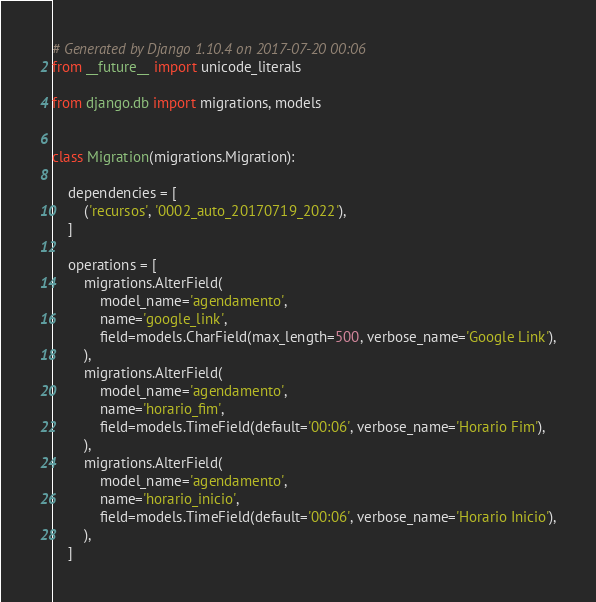Convert code to text. <code><loc_0><loc_0><loc_500><loc_500><_Python_># Generated by Django 1.10.4 on 2017-07-20 00:06
from __future__ import unicode_literals

from django.db import migrations, models


class Migration(migrations.Migration):

    dependencies = [
        ('recursos', '0002_auto_20170719_2022'),
    ]

    operations = [
        migrations.AlterField(
            model_name='agendamento',
            name='google_link',
            field=models.CharField(max_length=500, verbose_name='Google Link'),
        ),
        migrations.AlterField(
            model_name='agendamento',
            name='horario_fim',
            field=models.TimeField(default='00:06', verbose_name='Horario Fim'),
        ),
        migrations.AlterField(
            model_name='agendamento',
            name='horario_inicio',
            field=models.TimeField(default='00:06', verbose_name='Horario Inicio'),
        ),
    ]
</code> 